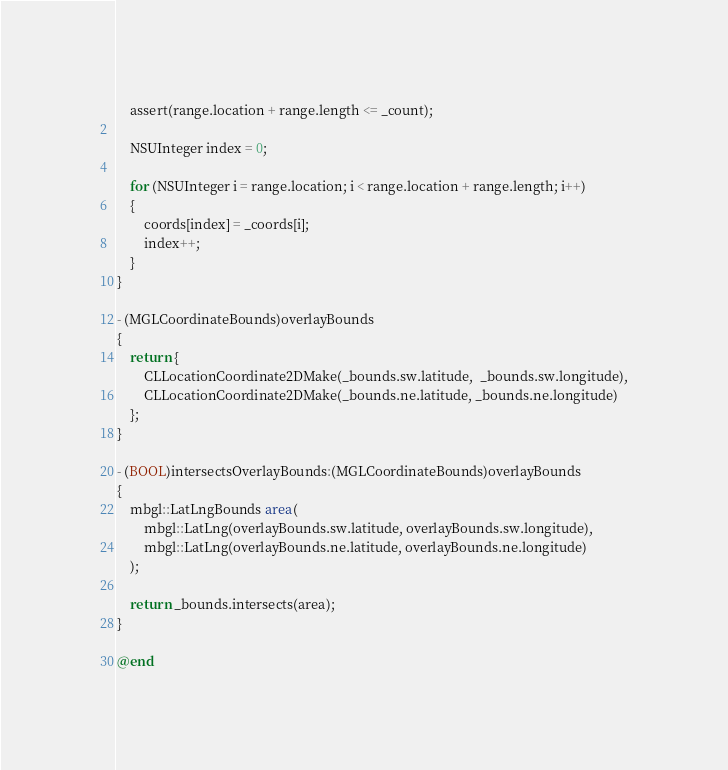Convert code to text. <code><loc_0><loc_0><loc_500><loc_500><_ObjectiveC_>
    assert(range.location + range.length <= _count);

    NSUInteger index = 0;

    for (NSUInteger i = range.location; i < range.location + range.length; i++)
    {
        coords[index] = _coords[i];
        index++;
    }
}

- (MGLCoordinateBounds)overlayBounds
{
    return {
        CLLocationCoordinate2DMake(_bounds.sw.latitude,  _bounds.sw.longitude),
        CLLocationCoordinate2DMake(_bounds.ne.latitude, _bounds.ne.longitude)
    };
}

- (BOOL)intersectsOverlayBounds:(MGLCoordinateBounds)overlayBounds
{
    mbgl::LatLngBounds area(
        mbgl::LatLng(overlayBounds.sw.latitude, overlayBounds.sw.longitude),
        mbgl::LatLng(overlayBounds.ne.latitude, overlayBounds.ne.longitude)
    );

    return _bounds.intersects(area);
}

@end
</code> 